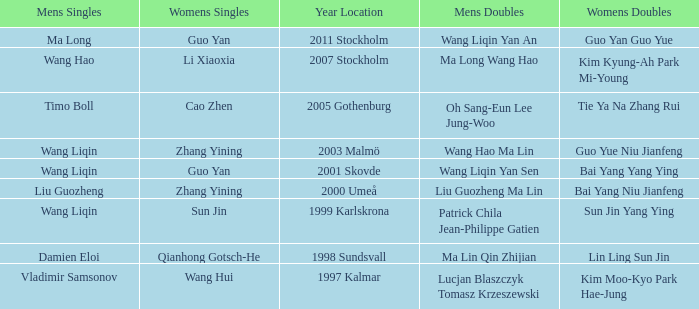What is the place and when was the year when the women's doubles womens were Bai yang Niu Jianfeng? 2000 Umeå. Write the full table. {'header': ['Mens Singles', 'Womens Singles', 'Year Location', 'Mens Doubles', 'Womens Doubles'], 'rows': [['Ma Long', 'Guo Yan', '2011 Stockholm', 'Wang Liqin Yan An', 'Guo Yan Guo Yue'], ['Wang Hao', 'Li Xiaoxia', '2007 Stockholm', 'Ma Long Wang Hao', 'Kim Kyung-Ah Park Mi-Young'], ['Timo Boll', 'Cao Zhen', '2005 Gothenburg', 'Oh Sang-Eun Lee Jung-Woo', 'Tie Ya Na Zhang Rui'], ['Wang Liqin', 'Zhang Yining', '2003 Malmö', 'Wang Hao Ma Lin', 'Guo Yue Niu Jianfeng'], ['Wang Liqin', 'Guo Yan', '2001 Skovde', 'Wang Liqin Yan Sen', 'Bai Yang Yang Ying'], ['Liu Guozheng', 'Zhang Yining', '2000 Umeå', 'Liu Guozheng Ma Lin', 'Bai Yang Niu Jianfeng'], ['Wang Liqin', 'Sun Jin', '1999 Karlskrona', 'Patrick Chila Jean-Philippe Gatien', 'Sun Jin Yang Ying'], ['Damien Eloi', 'Qianhong Gotsch-He', '1998 Sundsvall', 'Ma Lin Qin Zhijian', 'Lin Ling Sun Jin'], ['Vladimir Samsonov', 'Wang Hui', '1997 Kalmar', 'Lucjan Blaszczyk Tomasz Krzeszewski', 'Kim Moo-Kyo Park Hae-Jung']]} 